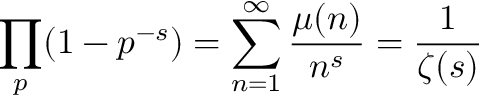Convert formula to latex. <formula><loc_0><loc_0><loc_500><loc_500>\prod _ { p } ( 1 - p ^ { - s } ) = \sum _ { n = 1 } ^ { \infty } { \frac { \mu ( n ) } { n ^ { s } } } = { \frac { 1 } { \zeta ( s ) } }</formula> 